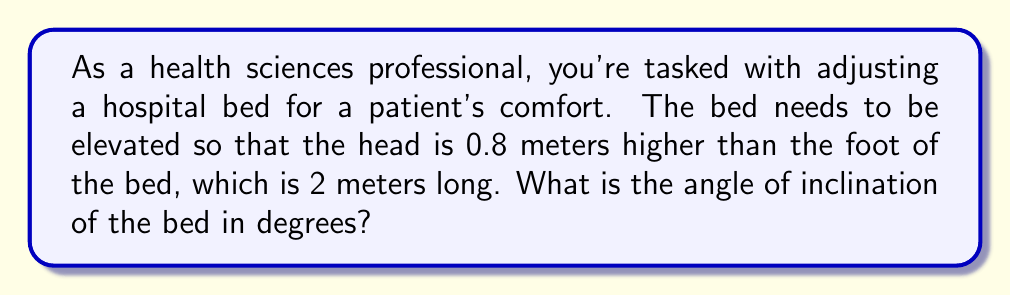Can you answer this question? Let's approach this step-by-step using trigonometry:

1) We can visualize this as a right triangle, where:
   - The base of the triangle is the length of the bed (2 meters)
   - The height is the elevation of the head (0.8 meters)
   - The hypotenuse is the bed surface
   - The angle we're looking for is between the base and the hypotenuse

2) We can use the tangent function to find this angle. Recall that:

   $$\tan(\theta) = \frac{\text{opposite}}{\text{adjacent}}$$

3) In our case:
   - opposite = 0.8 m (height)
   - adjacent = 2 m (length of the bed)

4) Let's plug these into the equation:

   $$\tan(\theta) = \frac{0.8}{2} = 0.4$$

5) To find $\theta$, we need to use the inverse tangent (arctan or $\tan^{-1}$):

   $$\theta = \tan^{-1}(0.4)$$

6) Using a calculator or computer:

   $$\theta \approx 21.8014^\circ$$

7) Rounding to two decimal places:

   $$\theta \approx 21.80^\circ$$
Answer: $21.80^\circ$ 